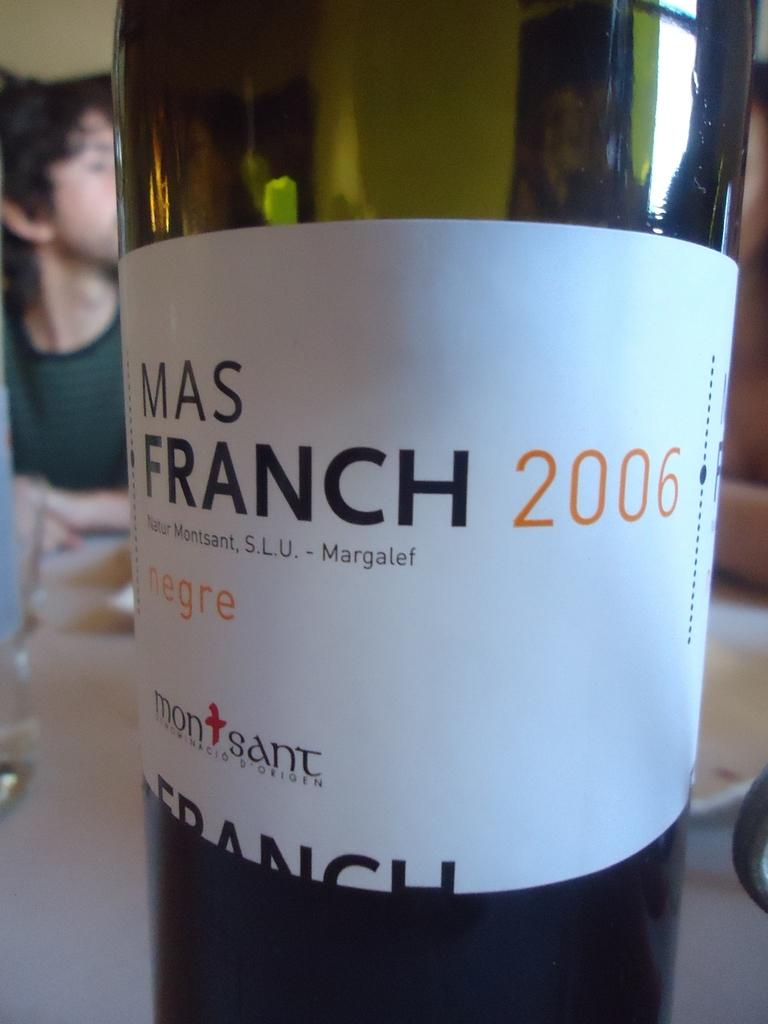Provide a one-sentence caption for the provided image. Mas Franch wine 2006 is sitting on a table. 